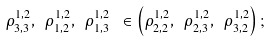<formula> <loc_0><loc_0><loc_500><loc_500>\rho ^ { 1 , 2 } _ { 3 , 3 } , \ \rho ^ { 1 , 2 } _ { 1 , 2 } , \ \rho ^ { 1 , 2 } _ { 1 , 3 } \ \in \left ( \rho ^ { 1 , 2 } _ { 2 , 2 } , \ \rho ^ { 1 , 2 } _ { 2 , 3 } , \ \rho ^ { 1 , 2 } _ { 3 , 2 } \right ) ;</formula> 